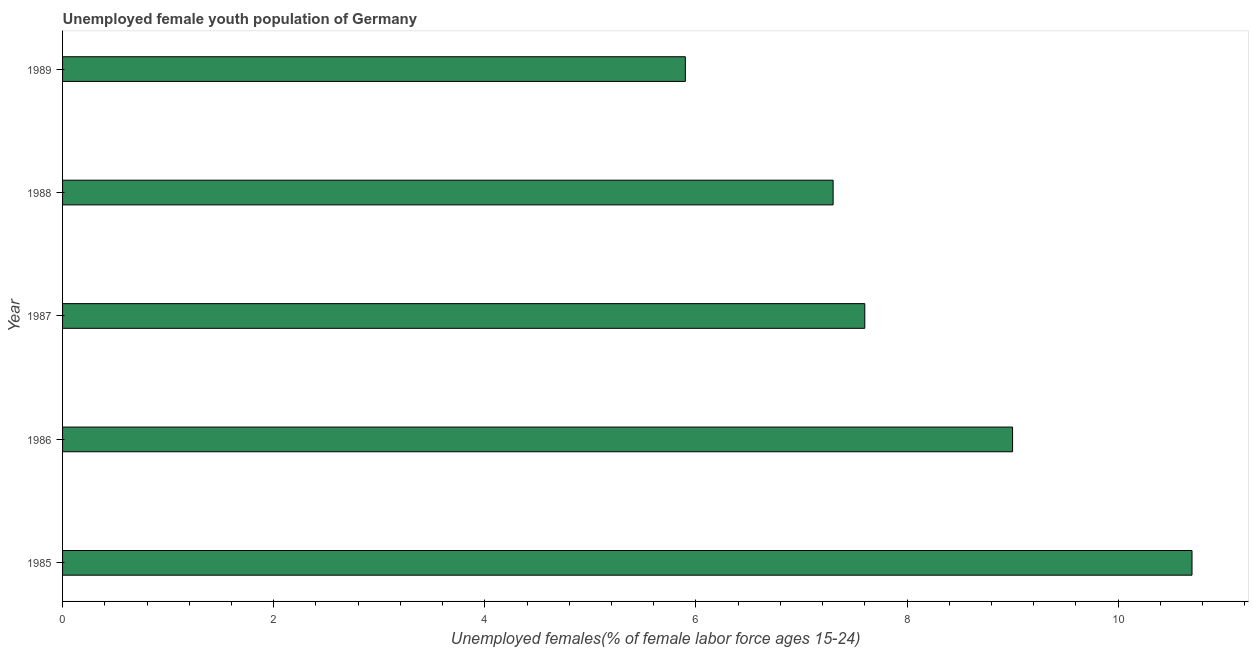Does the graph contain any zero values?
Offer a terse response. No. Does the graph contain grids?
Make the answer very short. No. What is the title of the graph?
Ensure brevity in your answer.  Unemployed female youth population of Germany. What is the label or title of the X-axis?
Keep it short and to the point. Unemployed females(% of female labor force ages 15-24). What is the unemployed female youth in 1987?
Your answer should be compact. 7.6. Across all years, what is the maximum unemployed female youth?
Your answer should be compact. 10.7. Across all years, what is the minimum unemployed female youth?
Keep it short and to the point. 5.9. In which year was the unemployed female youth minimum?
Your response must be concise. 1989. What is the sum of the unemployed female youth?
Provide a short and direct response. 40.5. What is the difference between the unemployed female youth in 1986 and 1987?
Your response must be concise. 1.4. What is the average unemployed female youth per year?
Give a very brief answer. 8.1. What is the median unemployed female youth?
Provide a succinct answer. 7.6. In how many years, is the unemployed female youth greater than 5.2 %?
Make the answer very short. 5. Do a majority of the years between 1988 and 1989 (inclusive) have unemployed female youth greater than 9.2 %?
Your response must be concise. No. What is the ratio of the unemployed female youth in 1987 to that in 1988?
Give a very brief answer. 1.04. Is the unemployed female youth in 1986 less than that in 1989?
Keep it short and to the point. No. What is the difference between the highest and the second highest unemployed female youth?
Provide a succinct answer. 1.7. What is the difference between the highest and the lowest unemployed female youth?
Your response must be concise. 4.8. In how many years, is the unemployed female youth greater than the average unemployed female youth taken over all years?
Your answer should be very brief. 2. Are the values on the major ticks of X-axis written in scientific E-notation?
Provide a short and direct response. No. What is the Unemployed females(% of female labor force ages 15-24) of 1985?
Your response must be concise. 10.7. What is the Unemployed females(% of female labor force ages 15-24) of 1986?
Offer a very short reply. 9. What is the Unemployed females(% of female labor force ages 15-24) in 1987?
Your answer should be compact. 7.6. What is the Unemployed females(% of female labor force ages 15-24) of 1988?
Offer a terse response. 7.3. What is the Unemployed females(% of female labor force ages 15-24) in 1989?
Offer a terse response. 5.9. What is the difference between the Unemployed females(% of female labor force ages 15-24) in 1985 and 1987?
Ensure brevity in your answer.  3.1. What is the difference between the Unemployed females(% of female labor force ages 15-24) in 1985 and 1989?
Offer a terse response. 4.8. What is the difference between the Unemployed females(% of female labor force ages 15-24) in 1986 and 1987?
Your answer should be compact. 1.4. What is the difference between the Unemployed females(% of female labor force ages 15-24) in 1986 and 1988?
Your answer should be compact. 1.7. What is the difference between the Unemployed females(% of female labor force ages 15-24) in 1987 and 1988?
Your answer should be very brief. 0.3. What is the difference between the Unemployed females(% of female labor force ages 15-24) in 1987 and 1989?
Provide a succinct answer. 1.7. What is the difference between the Unemployed females(% of female labor force ages 15-24) in 1988 and 1989?
Provide a short and direct response. 1.4. What is the ratio of the Unemployed females(% of female labor force ages 15-24) in 1985 to that in 1986?
Your answer should be compact. 1.19. What is the ratio of the Unemployed females(% of female labor force ages 15-24) in 1985 to that in 1987?
Provide a succinct answer. 1.41. What is the ratio of the Unemployed females(% of female labor force ages 15-24) in 1985 to that in 1988?
Provide a succinct answer. 1.47. What is the ratio of the Unemployed females(% of female labor force ages 15-24) in 1985 to that in 1989?
Provide a short and direct response. 1.81. What is the ratio of the Unemployed females(% of female labor force ages 15-24) in 1986 to that in 1987?
Offer a very short reply. 1.18. What is the ratio of the Unemployed females(% of female labor force ages 15-24) in 1986 to that in 1988?
Provide a short and direct response. 1.23. What is the ratio of the Unemployed females(% of female labor force ages 15-24) in 1986 to that in 1989?
Keep it short and to the point. 1.52. What is the ratio of the Unemployed females(% of female labor force ages 15-24) in 1987 to that in 1988?
Your response must be concise. 1.04. What is the ratio of the Unemployed females(% of female labor force ages 15-24) in 1987 to that in 1989?
Give a very brief answer. 1.29. What is the ratio of the Unemployed females(% of female labor force ages 15-24) in 1988 to that in 1989?
Ensure brevity in your answer.  1.24. 